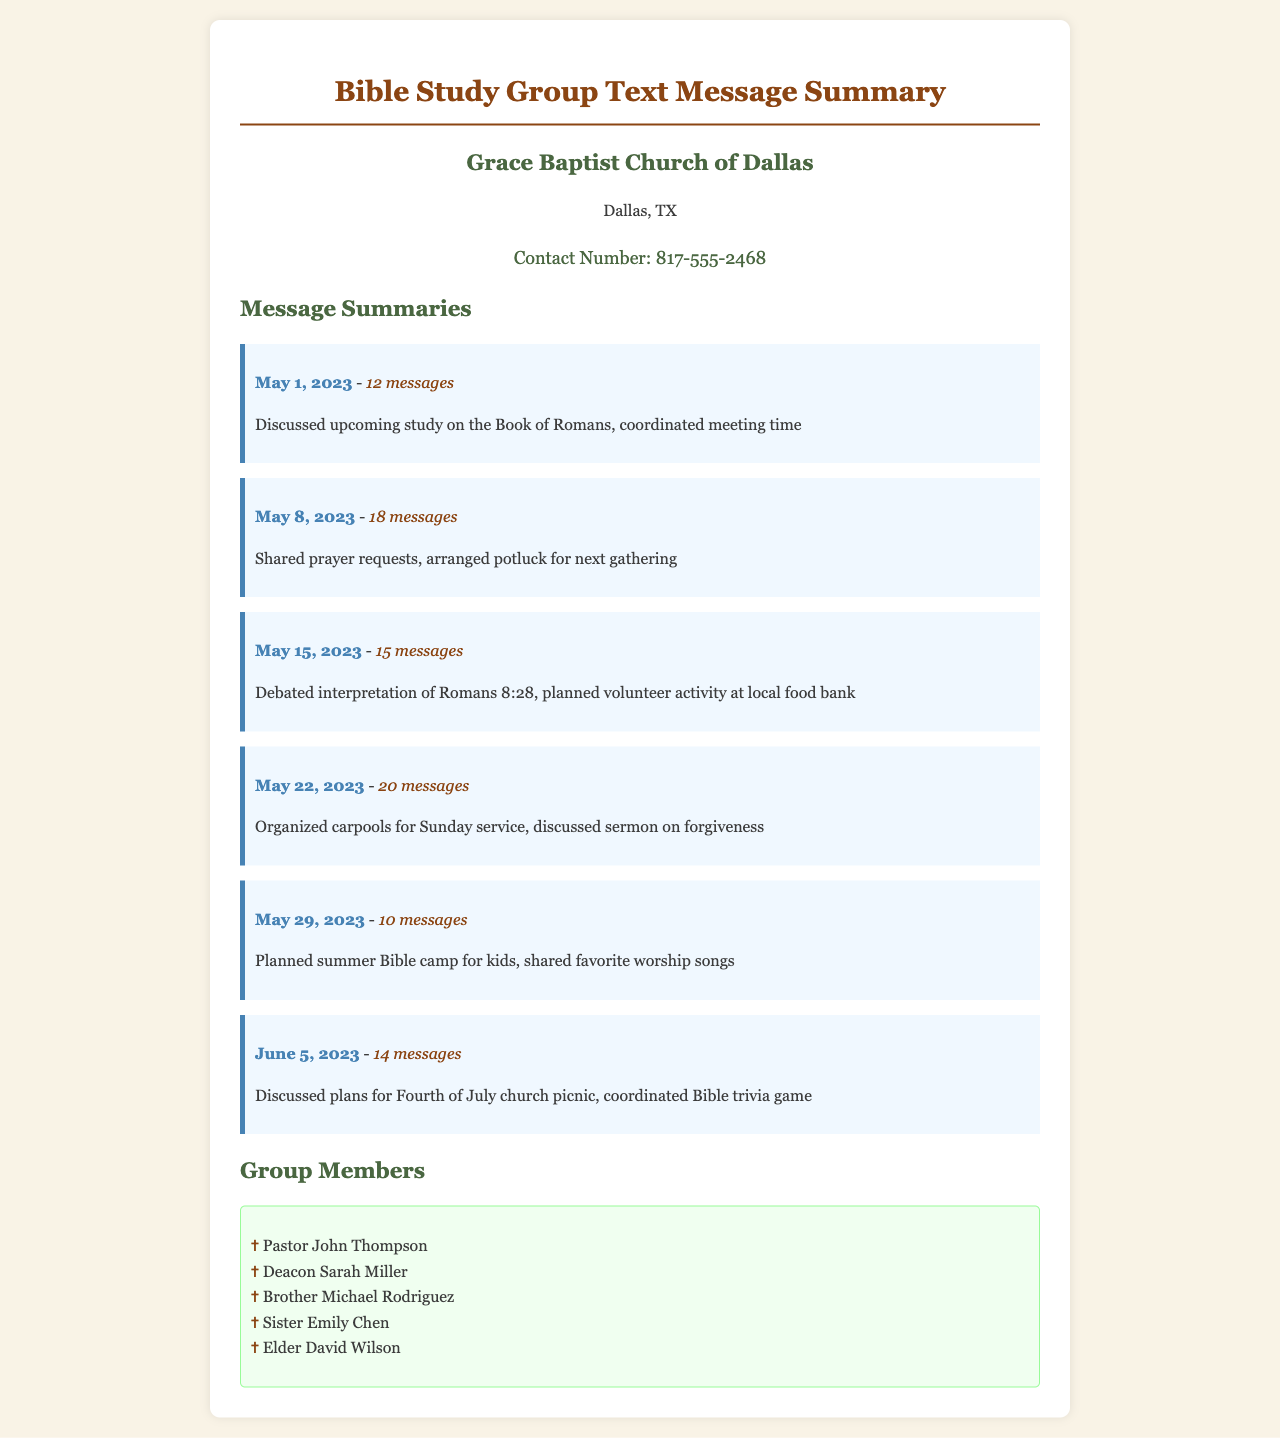What is the church name? The church name is mentioned in the document, specifying which church the Bible study group belongs to.
Answer: Grace Baptist Church of Dallas How many messages were exchanged on May 22, 2023? The number of messages is detailed under the date section for May 22, 2023, providing a specific count.
Answer: 20 messages What was discussed on May 1, 2023? The document lists the topics of discussion for each date, and May 1, 2023, included specific subjects.
Answer: Upcoming study on the Book of Romans Who coordinated the Bible trivia game? The individuals involved in the discussions and activities can give insight into the collaborative efforts among group members.
Answer: No specific individual mentioned How many total messages were exchanged across all dates? By summing all the message counts from the different dates, one can arrive at the total number of messages exchanged.
Answer: 99 messages What is the contact number listed? The contact information for the history requests appears prominently in the document, providing direct communication for group members.
Answer: 817-555-2468 Who is the first member listed in the group? The members of the Bible study group are listed in a specific order, thus making it simple to identify the first member.
Answer: Pastor John Thompson What activity was planned for May 29, 2023? The planned activities are explicitly stated under each date section, particularly for May 29, 2023.
Answer: Summer Bible camp for kids 